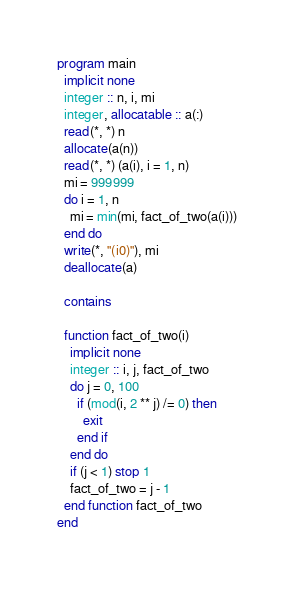<code> <loc_0><loc_0><loc_500><loc_500><_FORTRAN_>program main
  implicit none
  integer :: n, i, mi
  integer, allocatable :: a(:)
  read(*, *) n
  allocate(a(n))
  read(*, *) (a(i), i = 1, n)
  mi = 999999
  do i = 1, n
    mi = min(mi, fact_of_two(a(i)))
  end do
  write(*, "(i0)"), mi
  deallocate(a)

  contains

  function fact_of_two(i)
    implicit none
    integer :: i, j, fact_of_two
    do j = 0, 100
      if (mod(i, 2 ** j) /= 0) then
        exit
      end if
    end do
    if (j < 1) stop 1
    fact_of_two = j - 1
  end function fact_of_two
end
</code> 